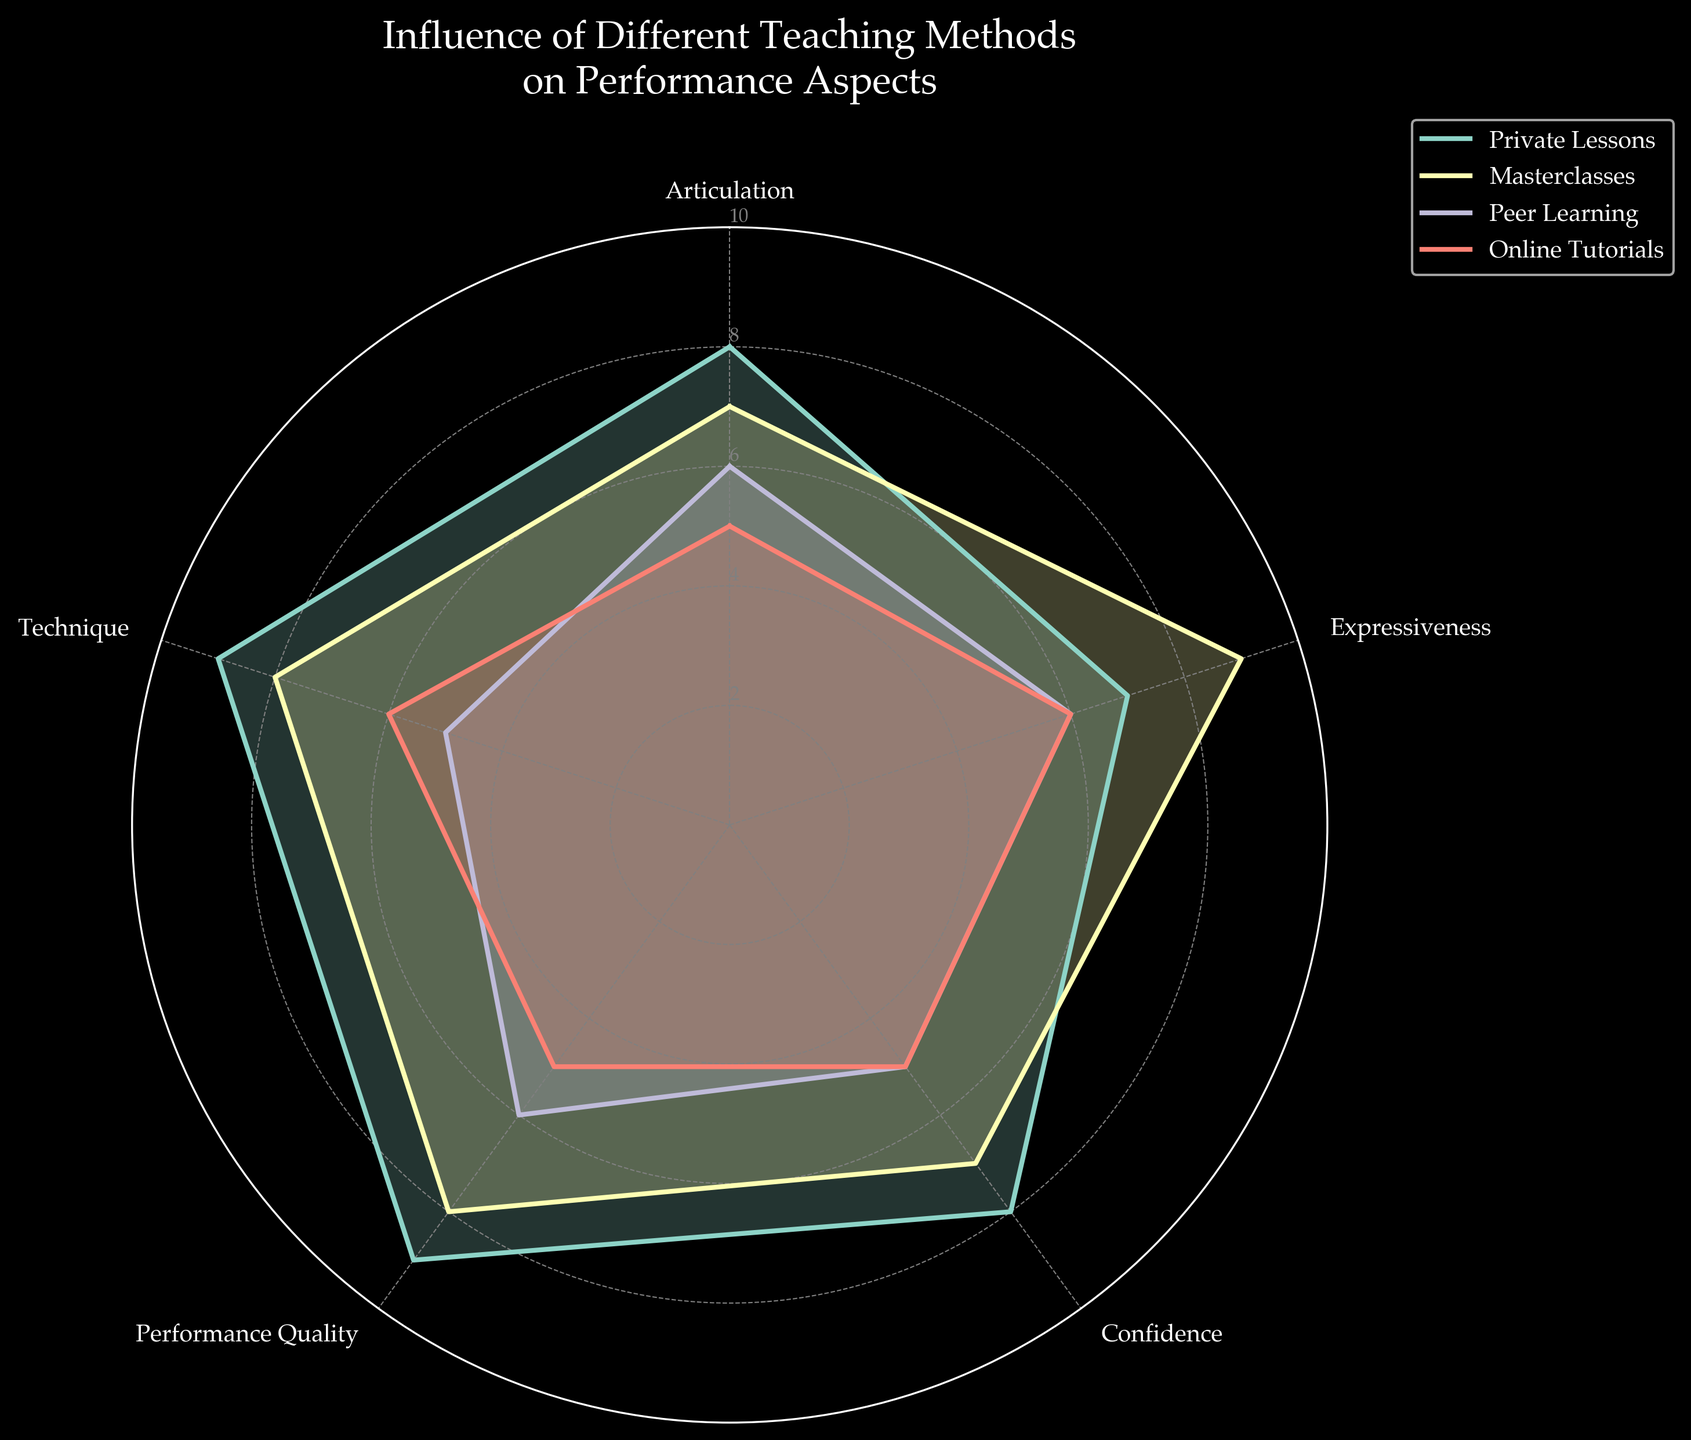What is the title of the radar chart? The title can be found at the top of the figure, which indicates the main subject of the chart.
Answer: Influence of Different Teaching Methods on Performance Aspects Which teaching method scored the highest in Technique? By examining the technique axis, we see the plot reaching its maximum along the axis for Private Lessons.
Answer: Private Lessons How many teaching methods are compared in the chart? By counting the number of distinct lines and shaded areas in the radar chart, we can determine the number of teaching methods analyzed.
Answer: Four Which teaching method has the lowest overall performance confidence? By looking at the Confidence axis, the plot that is closest to the center represents the lowest score.
Answer: Peer Learning and Online Tutorials Which category shows the largest difference between Private Lessons and Peer Learning? Check the difference in lengths of the radial arms between 'Private Lessons' and 'Peer Learning' across each performance category.
Answer: Technique (9 for Private Lessons, 5 for Peer Learning) In which categories do Online Tutorials and Peer Learning have the same scores? Compare the scores for both Online Tutorials and Peer Learning along each axis and identify the ones that match.
Answer: Expressiveness and Confidence Which teaching method shows the most balanced performance across all categories? Identify the method with the most similar scores (least variation) across all axes by examining the radar chart.
Answer: Masterclasses How many axes represent the performance aspects? Count the number of axes radiating from the center of the chart to see how many performance aspects are measured.
Answer: Five What is the difference in Expressiveness scores between Private Lessons and Masterclasses? Subtract the Expressiveness score of Private Lessons from that of Masterclasses (or vice versa depending on context).
Answer: 2 (7 for Private Lessons, 9 for Masterclasses) Which teaching method shows the lowest score in Articulation? Look at the Articulation axis and identify the teaching method with the shortest line in that direction.
Answer: Online Tutorials 